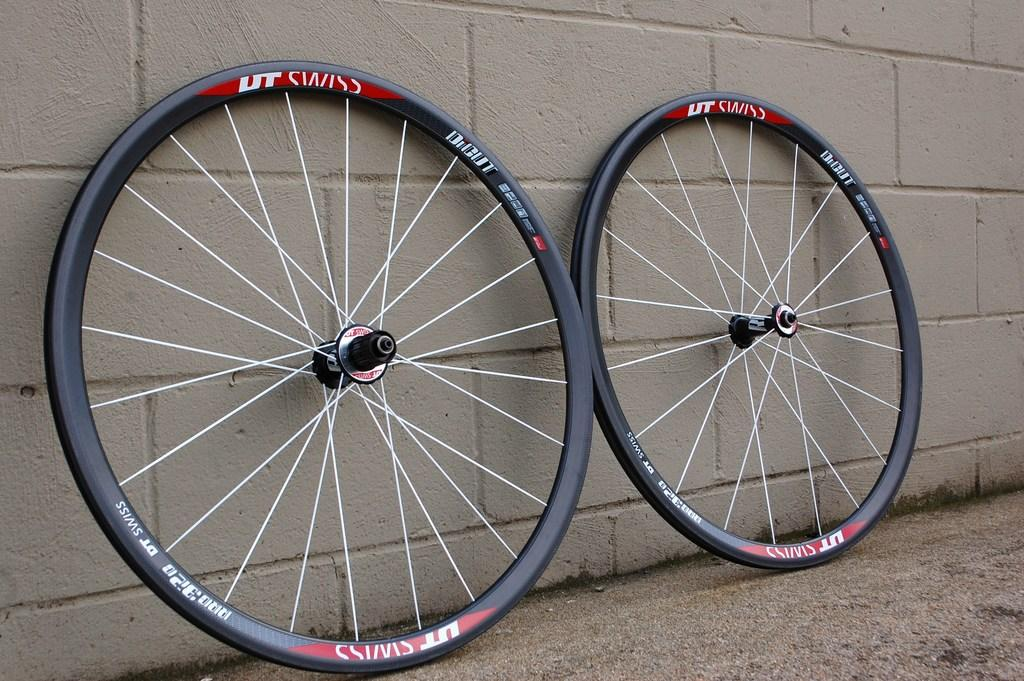What object is partially visible in the image? There are two wheels of a bicycle in the image. What can be seen in the background of the image? There is a wall visible in the background of the image. What type of bridge can be seen connecting the wheels of the bicycle in the image? There is no bridge present in the image; it only features two wheels of a bicycle and a wall in the background. 